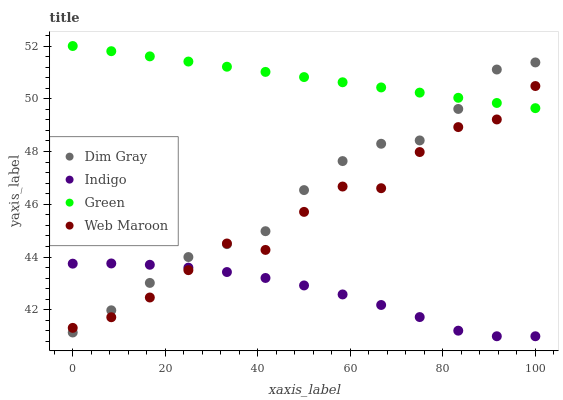Does Indigo have the minimum area under the curve?
Answer yes or no. Yes. Does Green have the maximum area under the curve?
Answer yes or no. Yes. Does Dim Gray have the minimum area under the curve?
Answer yes or no. No. Does Dim Gray have the maximum area under the curve?
Answer yes or no. No. Is Green the smoothest?
Answer yes or no. Yes. Is Web Maroon the roughest?
Answer yes or no. Yes. Is Dim Gray the smoothest?
Answer yes or no. No. Is Dim Gray the roughest?
Answer yes or no. No. Does Indigo have the lowest value?
Answer yes or no. Yes. Does Dim Gray have the lowest value?
Answer yes or no. No. Does Green have the highest value?
Answer yes or no. Yes. Does Dim Gray have the highest value?
Answer yes or no. No. Is Indigo less than Green?
Answer yes or no. Yes. Is Green greater than Indigo?
Answer yes or no. Yes. Does Web Maroon intersect Indigo?
Answer yes or no. Yes. Is Web Maroon less than Indigo?
Answer yes or no. No. Is Web Maroon greater than Indigo?
Answer yes or no. No. Does Indigo intersect Green?
Answer yes or no. No. 